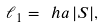Convert formula to latex. <formula><loc_0><loc_0><loc_500><loc_500>\ell _ { 1 } = \ h a \, | S | ,</formula> 